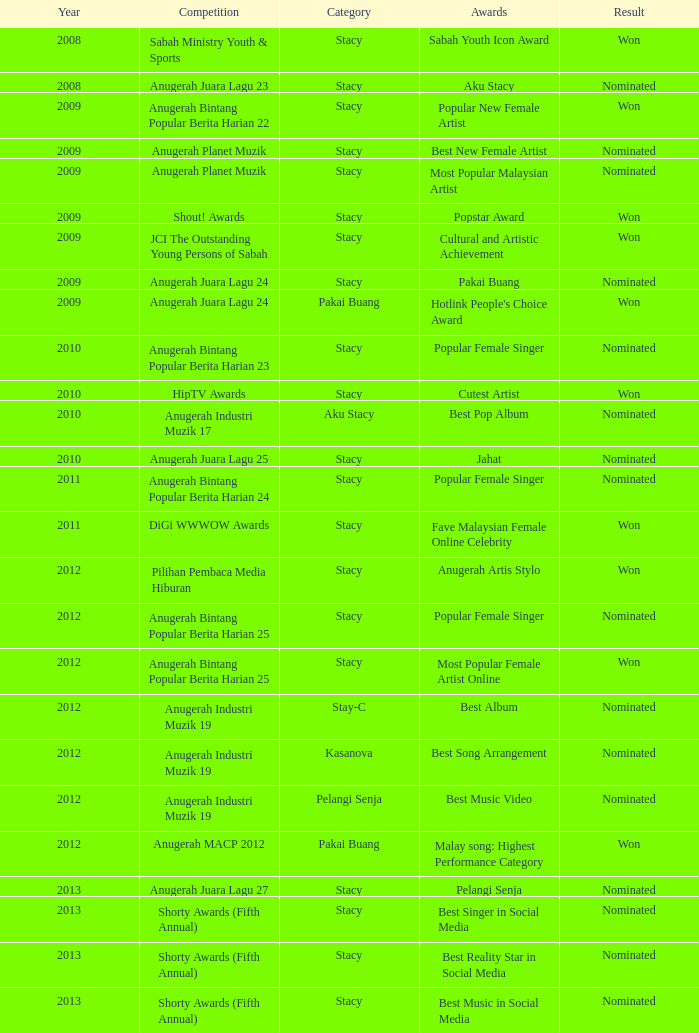What was the result in the year greaters than 2008 with an award of Jahat and had a category of Stacy? Nominated. 